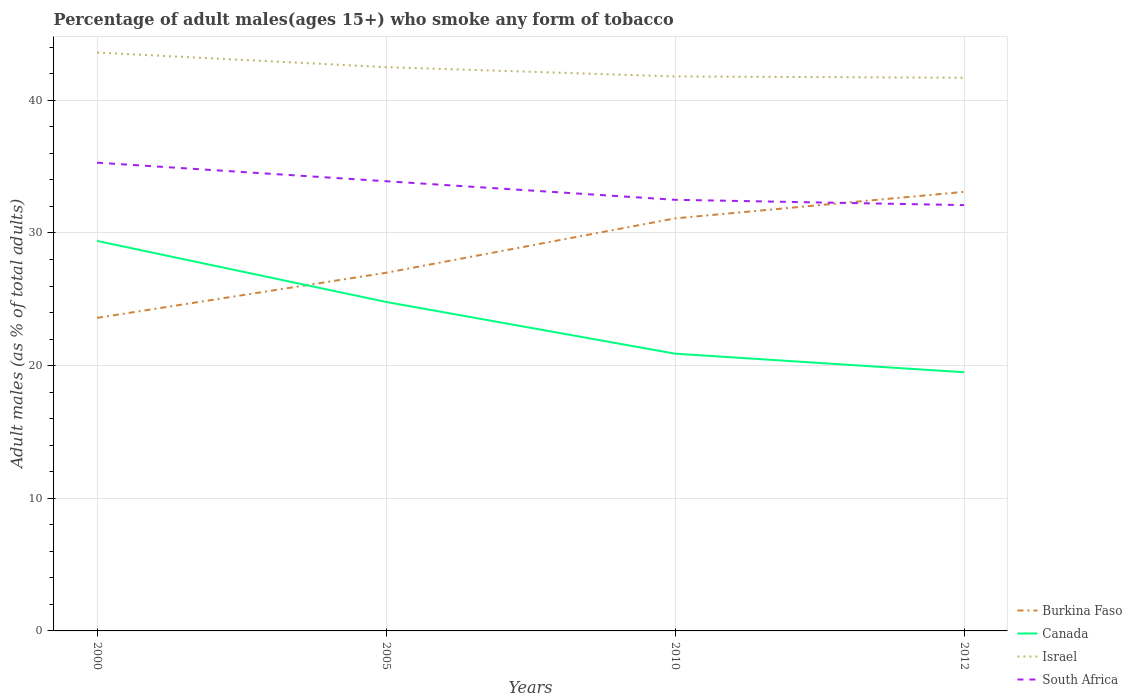Is the number of lines equal to the number of legend labels?
Your answer should be very brief. Yes. Across all years, what is the maximum percentage of adult males who smoke in Burkina Faso?
Offer a terse response. 23.6. In which year was the percentage of adult males who smoke in South Africa maximum?
Make the answer very short. 2012. What is the total percentage of adult males who smoke in South Africa in the graph?
Provide a succinct answer. 1.8. What is the difference between the highest and the second highest percentage of adult males who smoke in South Africa?
Your response must be concise. 3.2. What is the difference between two consecutive major ticks on the Y-axis?
Your response must be concise. 10. Are the values on the major ticks of Y-axis written in scientific E-notation?
Ensure brevity in your answer.  No. Where does the legend appear in the graph?
Offer a terse response. Bottom right. How many legend labels are there?
Offer a very short reply. 4. How are the legend labels stacked?
Give a very brief answer. Vertical. What is the title of the graph?
Offer a terse response. Percentage of adult males(ages 15+) who smoke any form of tobacco. Does "Mauritania" appear as one of the legend labels in the graph?
Your answer should be compact. No. What is the label or title of the X-axis?
Ensure brevity in your answer.  Years. What is the label or title of the Y-axis?
Provide a short and direct response. Adult males (as % of total adults). What is the Adult males (as % of total adults) of Burkina Faso in 2000?
Offer a very short reply. 23.6. What is the Adult males (as % of total adults) in Canada in 2000?
Make the answer very short. 29.4. What is the Adult males (as % of total adults) in Israel in 2000?
Your answer should be very brief. 43.6. What is the Adult males (as % of total adults) in South Africa in 2000?
Make the answer very short. 35.3. What is the Adult males (as % of total adults) of Canada in 2005?
Offer a terse response. 24.8. What is the Adult males (as % of total adults) of Israel in 2005?
Provide a succinct answer. 42.5. What is the Adult males (as % of total adults) in South Africa in 2005?
Provide a succinct answer. 33.9. What is the Adult males (as % of total adults) in Burkina Faso in 2010?
Provide a short and direct response. 31.1. What is the Adult males (as % of total adults) of Canada in 2010?
Ensure brevity in your answer.  20.9. What is the Adult males (as % of total adults) of Israel in 2010?
Provide a succinct answer. 41.8. What is the Adult males (as % of total adults) in South Africa in 2010?
Provide a short and direct response. 32.5. What is the Adult males (as % of total adults) in Burkina Faso in 2012?
Your answer should be very brief. 33.1. What is the Adult males (as % of total adults) in Israel in 2012?
Provide a succinct answer. 41.7. What is the Adult males (as % of total adults) in South Africa in 2012?
Offer a terse response. 32.1. Across all years, what is the maximum Adult males (as % of total adults) in Burkina Faso?
Offer a very short reply. 33.1. Across all years, what is the maximum Adult males (as % of total adults) in Canada?
Your answer should be compact. 29.4. Across all years, what is the maximum Adult males (as % of total adults) of Israel?
Offer a very short reply. 43.6. Across all years, what is the maximum Adult males (as % of total adults) of South Africa?
Offer a very short reply. 35.3. Across all years, what is the minimum Adult males (as % of total adults) of Burkina Faso?
Ensure brevity in your answer.  23.6. Across all years, what is the minimum Adult males (as % of total adults) in Canada?
Make the answer very short. 19.5. Across all years, what is the minimum Adult males (as % of total adults) of Israel?
Your response must be concise. 41.7. Across all years, what is the minimum Adult males (as % of total adults) in South Africa?
Ensure brevity in your answer.  32.1. What is the total Adult males (as % of total adults) in Burkina Faso in the graph?
Your answer should be very brief. 114.8. What is the total Adult males (as % of total adults) of Canada in the graph?
Offer a very short reply. 94.6. What is the total Adult males (as % of total adults) of Israel in the graph?
Keep it short and to the point. 169.6. What is the total Adult males (as % of total adults) of South Africa in the graph?
Provide a short and direct response. 133.8. What is the difference between the Adult males (as % of total adults) in Burkina Faso in 2000 and that in 2005?
Your answer should be very brief. -3.4. What is the difference between the Adult males (as % of total adults) of Canada in 2000 and that in 2005?
Your response must be concise. 4.6. What is the difference between the Adult males (as % of total adults) in Burkina Faso in 2000 and that in 2010?
Ensure brevity in your answer.  -7.5. What is the difference between the Adult males (as % of total adults) of South Africa in 2000 and that in 2012?
Give a very brief answer. 3.2. What is the difference between the Adult males (as % of total adults) of Burkina Faso in 2005 and that in 2010?
Give a very brief answer. -4.1. What is the difference between the Adult males (as % of total adults) of Canada in 2005 and that in 2010?
Your answer should be very brief. 3.9. What is the difference between the Adult males (as % of total adults) of Israel in 2005 and that in 2010?
Provide a short and direct response. 0.7. What is the difference between the Adult males (as % of total adults) in South Africa in 2005 and that in 2010?
Provide a short and direct response. 1.4. What is the difference between the Adult males (as % of total adults) of Burkina Faso in 2005 and that in 2012?
Ensure brevity in your answer.  -6.1. What is the difference between the Adult males (as % of total adults) of Canada in 2005 and that in 2012?
Provide a short and direct response. 5.3. What is the difference between the Adult males (as % of total adults) in South Africa in 2005 and that in 2012?
Offer a very short reply. 1.8. What is the difference between the Adult males (as % of total adults) in Burkina Faso in 2010 and that in 2012?
Provide a succinct answer. -2. What is the difference between the Adult males (as % of total adults) of Canada in 2010 and that in 2012?
Provide a succinct answer. 1.4. What is the difference between the Adult males (as % of total adults) of Burkina Faso in 2000 and the Adult males (as % of total adults) of Canada in 2005?
Make the answer very short. -1.2. What is the difference between the Adult males (as % of total adults) in Burkina Faso in 2000 and the Adult males (as % of total adults) in Israel in 2005?
Offer a very short reply. -18.9. What is the difference between the Adult males (as % of total adults) in Canada in 2000 and the Adult males (as % of total adults) in Israel in 2005?
Offer a terse response. -13.1. What is the difference between the Adult males (as % of total adults) of Canada in 2000 and the Adult males (as % of total adults) of South Africa in 2005?
Your response must be concise. -4.5. What is the difference between the Adult males (as % of total adults) in Burkina Faso in 2000 and the Adult males (as % of total adults) in Israel in 2010?
Your answer should be very brief. -18.2. What is the difference between the Adult males (as % of total adults) of Burkina Faso in 2000 and the Adult males (as % of total adults) of South Africa in 2010?
Provide a succinct answer. -8.9. What is the difference between the Adult males (as % of total adults) of Canada in 2000 and the Adult males (as % of total adults) of Israel in 2010?
Make the answer very short. -12.4. What is the difference between the Adult males (as % of total adults) of Israel in 2000 and the Adult males (as % of total adults) of South Africa in 2010?
Offer a very short reply. 11.1. What is the difference between the Adult males (as % of total adults) of Burkina Faso in 2000 and the Adult males (as % of total adults) of Israel in 2012?
Your answer should be compact. -18.1. What is the difference between the Adult males (as % of total adults) of Canada in 2000 and the Adult males (as % of total adults) of Israel in 2012?
Make the answer very short. -12.3. What is the difference between the Adult males (as % of total adults) in Israel in 2000 and the Adult males (as % of total adults) in South Africa in 2012?
Make the answer very short. 11.5. What is the difference between the Adult males (as % of total adults) in Burkina Faso in 2005 and the Adult males (as % of total adults) in Israel in 2010?
Offer a terse response. -14.8. What is the difference between the Adult males (as % of total adults) of Burkina Faso in 2005 and the Adult males (as % of total adults) of South Africa in 2010?
Make the answer very short. -5.5. What is the difference between the Adult males (as % of total adults) of Burkina Faso in 2005 and the Adult males (as % of total adults) of Canada in 2012?
Keep it short and to the point. 7.5. What is the difference between the Adult males (as % of total adults) in Burkina Faso in 2005 and the Adult males (as % of total adults) in Israel in 2012?
Ensure brevity in your answer.  -14.7. What is the difference between the Adult males (as % of total adults) of Canada in 2005 and the Adult males (as % of total adults) of Israel in 2012?
Provide a succinct answer. -16.9. What is the difference between the Adult males (as % of total adults) of Canada in 2005 and the Adult males (as % of total adults) of South Africa in 2012?
Keep it short and to the point. -7.3. What is the difference between the Adult males (as % of total adults) in Israel in 2005 and the Adult males (as % of total adults) in South Africa in 2012?
Your answer should be very brief. 10.4. What is the difference between the Adult males (as % of total adults) of Burkina Faso in 2010 and the Adult males (as % of total adults) of Canada in 2012?
Your answer should be very brief. 11.6. What is the difference between the Adult males (as % of total adults) of Burkina Faso in 2010 and the Adult males (as % of total adults) of South Africa in 2012?
Offer a very short reply. -1. What is the difference between the Adult males (as % of total adults) in Canada in 2010 and the Adult males (as % of total adults) in Israel in 2012?
Make the answer very short. -20.8. What is the average Adult males (as % of total adults) of Burkina Faso per year?
Keep it short and to the point. 28.7. What is the average Adult males (as % of total adults) of Canada per year?
Make the answer very short. 23.65. What is the average Adult males (as % of total adults) of Israel per year?
Give a very brief answer. 42.4. What is the average Adult males (as % of total adults) in South Africa per year?
Provide a short and direct response. 33.45. In the year 2000, what is the difference between the Adult males (as % of total adults) in Burkina Faso and Adult males (as % of total adults) in Israel?
Provide a succinct answer. -20. In the year 2000, what is the difference between the Adult males (as % of total adults) in Canada and Adult males (as % of total adults) in Israel?
Offer a very short reply. -14.2. In the year 2005, what is the difference between the Adult males (as % of total adults) of Burkina Faso and Adult males (as % of total adults) of Israel?
Your answer should be very brief. -15.5. In the year 2005, what is the difference between the Adult males (as % of total adults) of Canada and Adult males (as % of total adults) of Israel?
Provide a short and direct response. -17.7. In the year 2005, what is the difference between the Adult males (as % of total adults) of Canada and Adult males (as % of total adults) of South Africa?
Provide a succinct answer. -9.1. In the year 2010, what is the difference between the Adult males (as % of total adults) in Burkina Faso and Adult males (as % of total adults) in South Africa?
Give a very brief answer. -1.4. In the year 2010, what is the difference between the Adult males (as % of total adults) of Canada and Adult males (as % of total adults) of Israel?
Your answer should be compact. -20.9. In the year 2010, what is the difference between the Adult males (as % of total adults) of Canada and Adult males (as % of total adults) of South Africa?
Provide a short and direct response. -11.6. In the year 2010, what is the difference between the Adult males (as % of total adults) in Israel and Adult males (as % of total adults) in South Africa?
Offer a terse response. 9.3. In the year 2012, what is the difference between the Adult males (as % of total adults) in Canada and Adult males (as % of total adults) in Israel?
Your response must be concise. -22.2. What is the ratio of the Adult males (as % of total adults) of Burkina Faso in 2000 to that in 2005?
Your answer should be very brief. 0.87. What is the ratio of the Adult males (as % of total adults) of Canada in 2000 to that in 2005?
Keep it short and to the point. 1.19. What is the ratio of the Adult males (as % of total adults) in Israel in 2000 to that in 2005?
Ensure brevity in your answer.  1.03. What is the ratio of the Adult males (as % of total adults) in South Africa in 2000 to that in 2005?
Your response must be concise. 1.04. What is the ratio of the Adult males (as % of total adults) of Burkina Faso in 2000 to that in 2010?
Your response must be concise. 0.76. What is the ratio of the Adult males (as % of total adults) in Canada in 2000 to that in 2010?
Your answer should be compact. 1.41. What is the ratio of the Adult males (as % of total adults) in Israel in 2000 to that in 2010?
Give a very brief answer. 1.04. What is the ratio of the Adult males (as % of total adults) in South Africa in 2000 to that in 2010?
Make the answer very short. 1.09. What is the ratio of the Adult males (as % of total adults) in Burkina Faso in 2000 to that in 2012?
Your answer should be very brief. 0.71. What is the ratio of the Adult males (as % of total adults) in Canada in 2000 to that in 2012?
Offer a very short reply. 1.51. What is the ratio of the Adult males (as % of total adults) in Israel in 2000 to that in 2012?
Keep it short and to the point. 1.05. What is the ratio of the Adult males (as % of total adults) in South Africa in 2000 to that in 2012?
Make the answer very short. 1.1. What is the ratio of the Adult males (as % of total adults) in Burkina Faso in 2005 to that in 2010?
Offer a very short reply. 0.87. What is the ratio of the Adult males (as % of total adults) of Canada in 2005 to that in 2010?
Provide a succinct answer. 1.19. What is the ratio of the Adult males (as % of total adults) in Israel in 2005 to that in 2010?
Your response must be concise. 1.02. What is the ratio of the Adult males (as % of total adults) of South Africa in 2005 to that in 2010?
Make the answer very short. 1.04. What is the ratio of the Adult males (as % of total adults) in Burkina Faso in 2005 to that in 2012?
Give a very brief answer. 0.82. What is the ratio of the Adult males (as % of total adults) of Canada in 2005 to that in 2012?
Your answer should be compact. 1.27. What is the ratio of the Adult males (as % of total adults) of Israel in 2005 to that in 2012?
Make the answer very short. 1.02. What is the ratio of the Adult males (as % of total adults) of South Africa in 2005 to that in 2012?
Make the answer very short. 1.06. What is the ratio of the Adult males (as % of total adults) in Burkina Faso in 2010 to that in 2012?
Provide a succinct answer. 0.94. What is the ratio of the Adult males (as % of total adults) of Canada in 2010 to that in 2012?
Your answer should be compact. 1.07. What is the ratio of the Adult males (as % of total adults) in South Africa in 2010 to that in 2012?
Offer a very short reply. 1.01. What is the difference between the highest and the second highest Adult males (as % of total adults) of Canada?
Your response must be concise. 4.6. What is the difference between the highest and the lowest Adult males (as % of total adults) in Burkina Faso?
Make the answer very short. 9.5. 